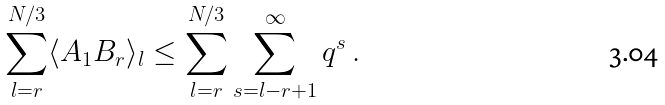<formula> <loc_0><loc_0><loc_500><loc_500>\sum _ { l = r } ^ { N / 3 } \langle A _ { 1 } B _ { r } \rangle _ { l } \leq \sum _ { l = r } ^ { N / 3 } \sum _ { s = l - r + 1 } ^ { \infty } q ^ { s } \, .</formula> 